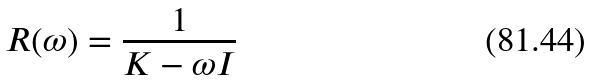Convert formula to latex. <formula><loc_0><loc_0><loc_500><loc_500>R ( \omega ) = \frac { 1 } { K - \omega I }</formula> 